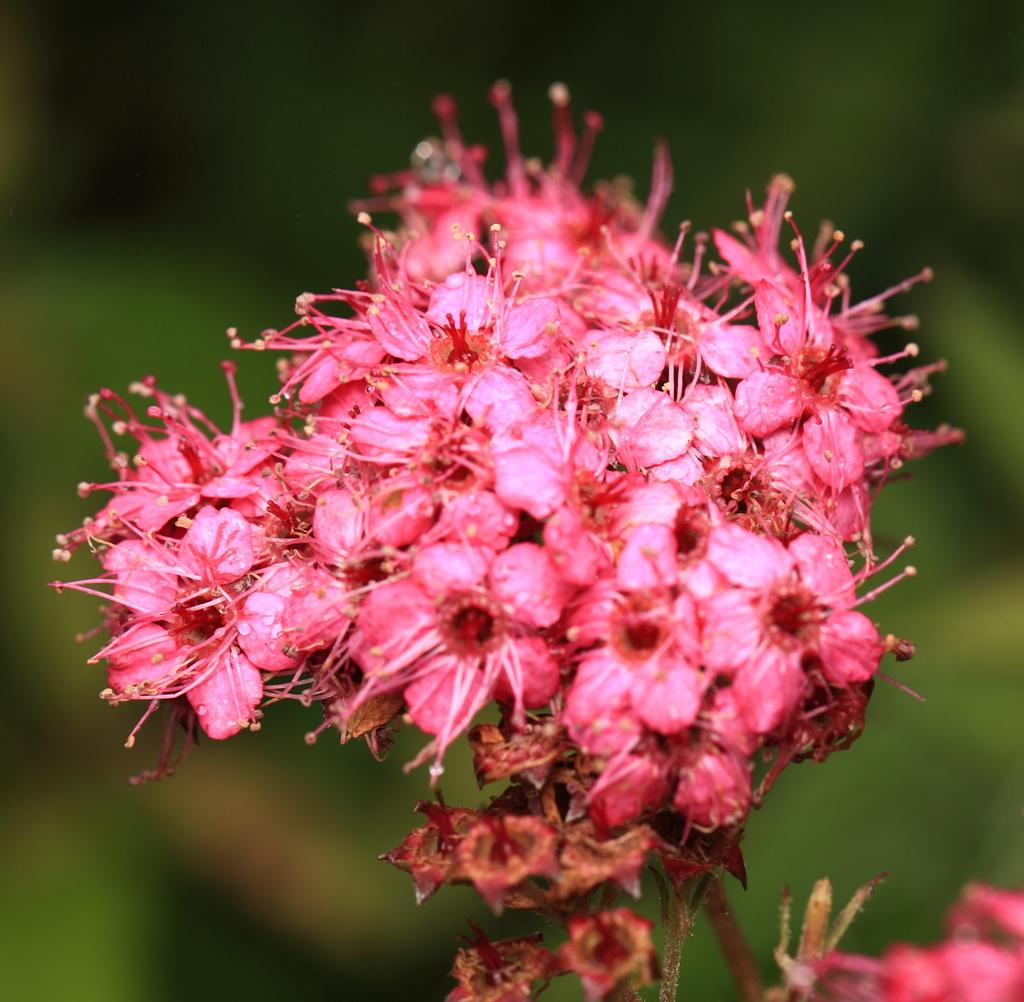What type of living organisms can be seen in the image? There are flowers in the image. Can you describe the background of the image? The background of the image is blurred. What appliance is visible in the image? There is no appliance present in the image. What route can be seen in the image? There is no route visible in the image; it only features flowers and a blurred background. 